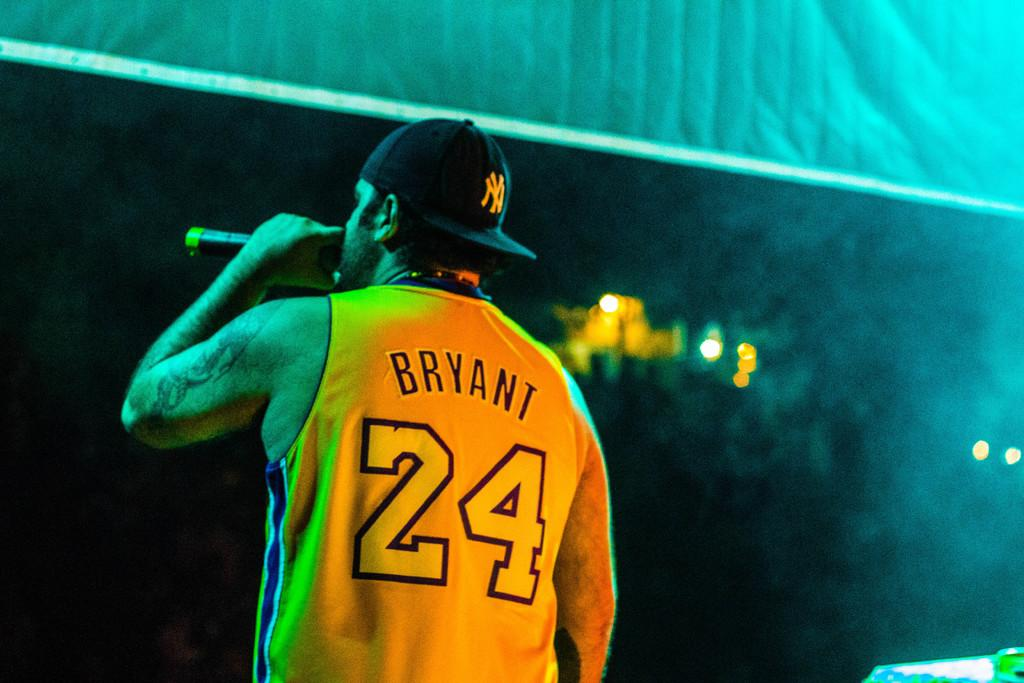<image>
Relay a brief, clear account of the picture shown. A man singing into a microphone wearing a Bryant 24 jersey. 